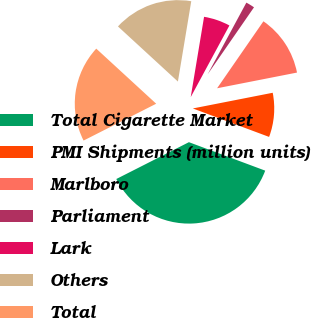Convert chart. <chart><loc_0><loc_0><loc_500><loc_500><pie_chart><fcel>Total Cigarette Market<fcel>PMI Shipments (million units)<fcel>Marlboro<fcel>Parliament<fcel>Lark<fcel>Others<fcel>Total<nl><fcel>36.84%<fcel>8.77%<fcel>12.28%<fcel>1.75%<fcel>5.26%<fcel>15.79%<fcel>19.3%<nl></chart> 